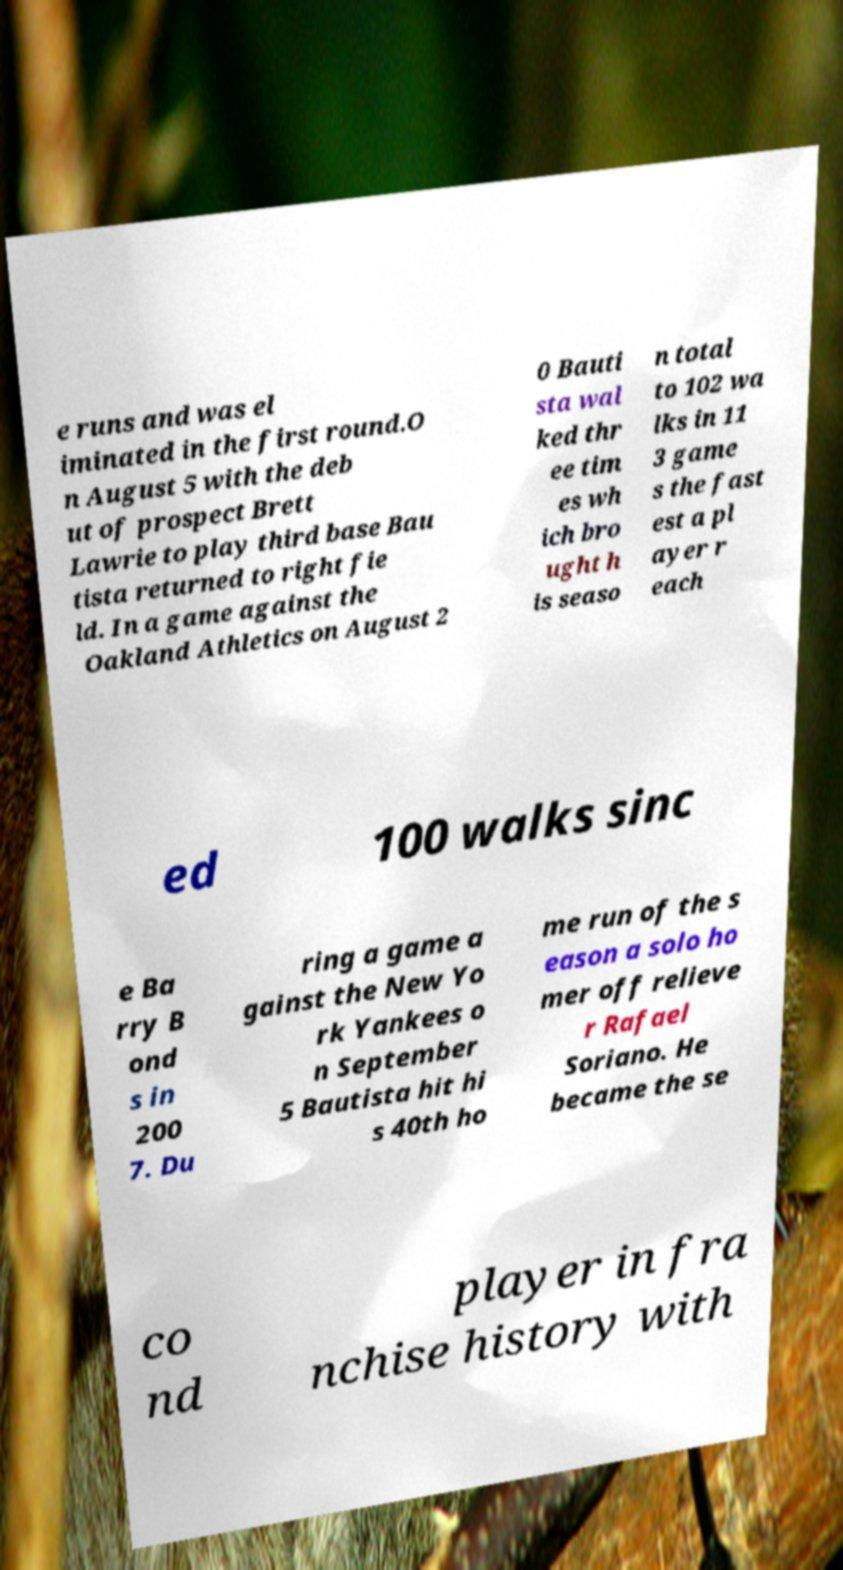I need the written content from this picture converted into text. Can you do that? e runs and was el iminated in the first round.O n August 5 with the deb ut of prospect Brett Lawrie to play third base Bau tista returned to right fie ld. In a game against the Oakland Athletics on August 2 0 Bauti sta wal ked thr ee tim es wh ich bro ught h is seaso n total to 102 wa lks in 11 3 game s the fast est a pl ayer r each ed 100 walks sinc e Ba rry B ond s in 200 7. Du ring a game a gainst the New Yo rk Yankees o n September 5 Bautista hit hi s 40th ho me run of the s eason a solo ho mer off relieve r Rafael Soriano. He became the se co nd player in fra nchise history with 